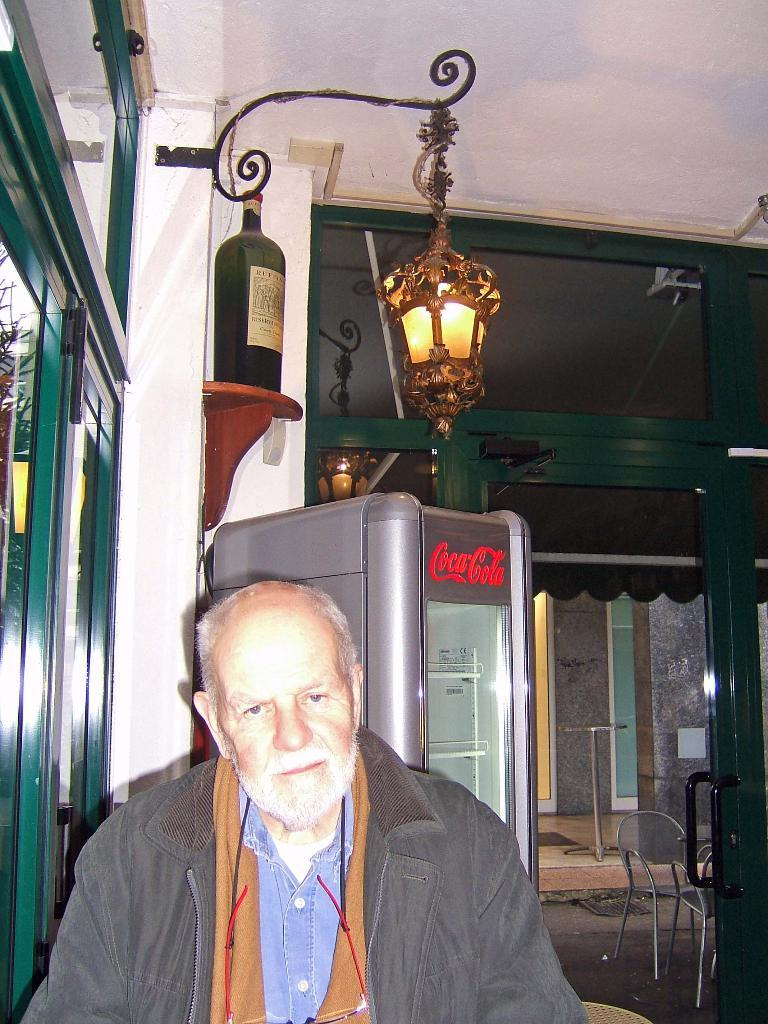Who is present in the image? There is a man in the image. What object is located behind the man? There is a bottle behind the man. What source of illumination is visible in the image? There is a light in the image. What type of appliance can be seen in the image? There is a refrigerator in the image. What type of furniture is present in the image? There are chairs in the image. Can you tell me the color of the boat in the image? There is no boat present in the image. 